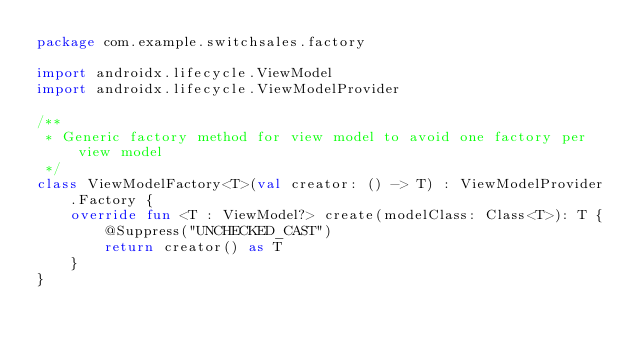Convert code to text. <code><loc_0><loc_0><loc_500><loc_500><_Kotlin_>package com.example.switchsales.factory

import androidx.lifecycle.ViewModel
import androidx.lifecycle.ViewModelProvider

/**
 * Generic factory method for view model to avoid one factory per view model
 */
class ViewModelFactory<T>(val creator: () -> T) : ViewModelProvider.Factory {
    override fun <T : ViewModel?> create(modelClass: Class<T>): T {
        @Suppress("UNCHECKED_CAST")
        return creator() as T
    }
}</code> 